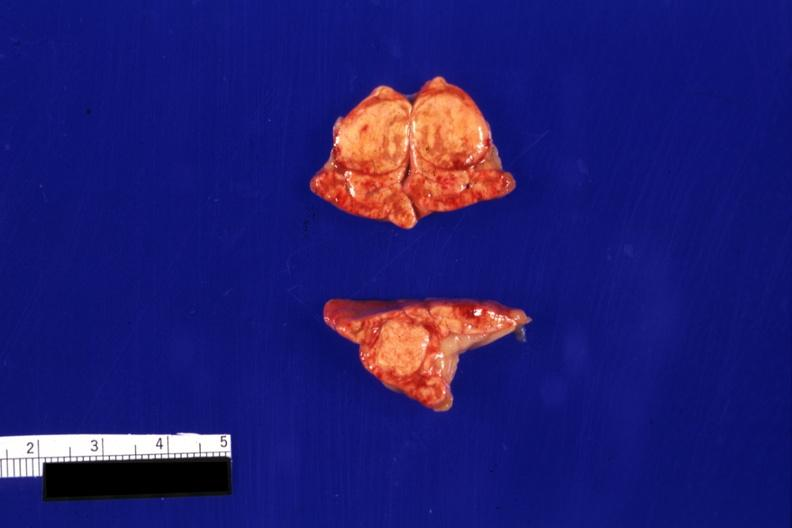s adrenal present?
Answer the question using a single word or phrase. Yes 